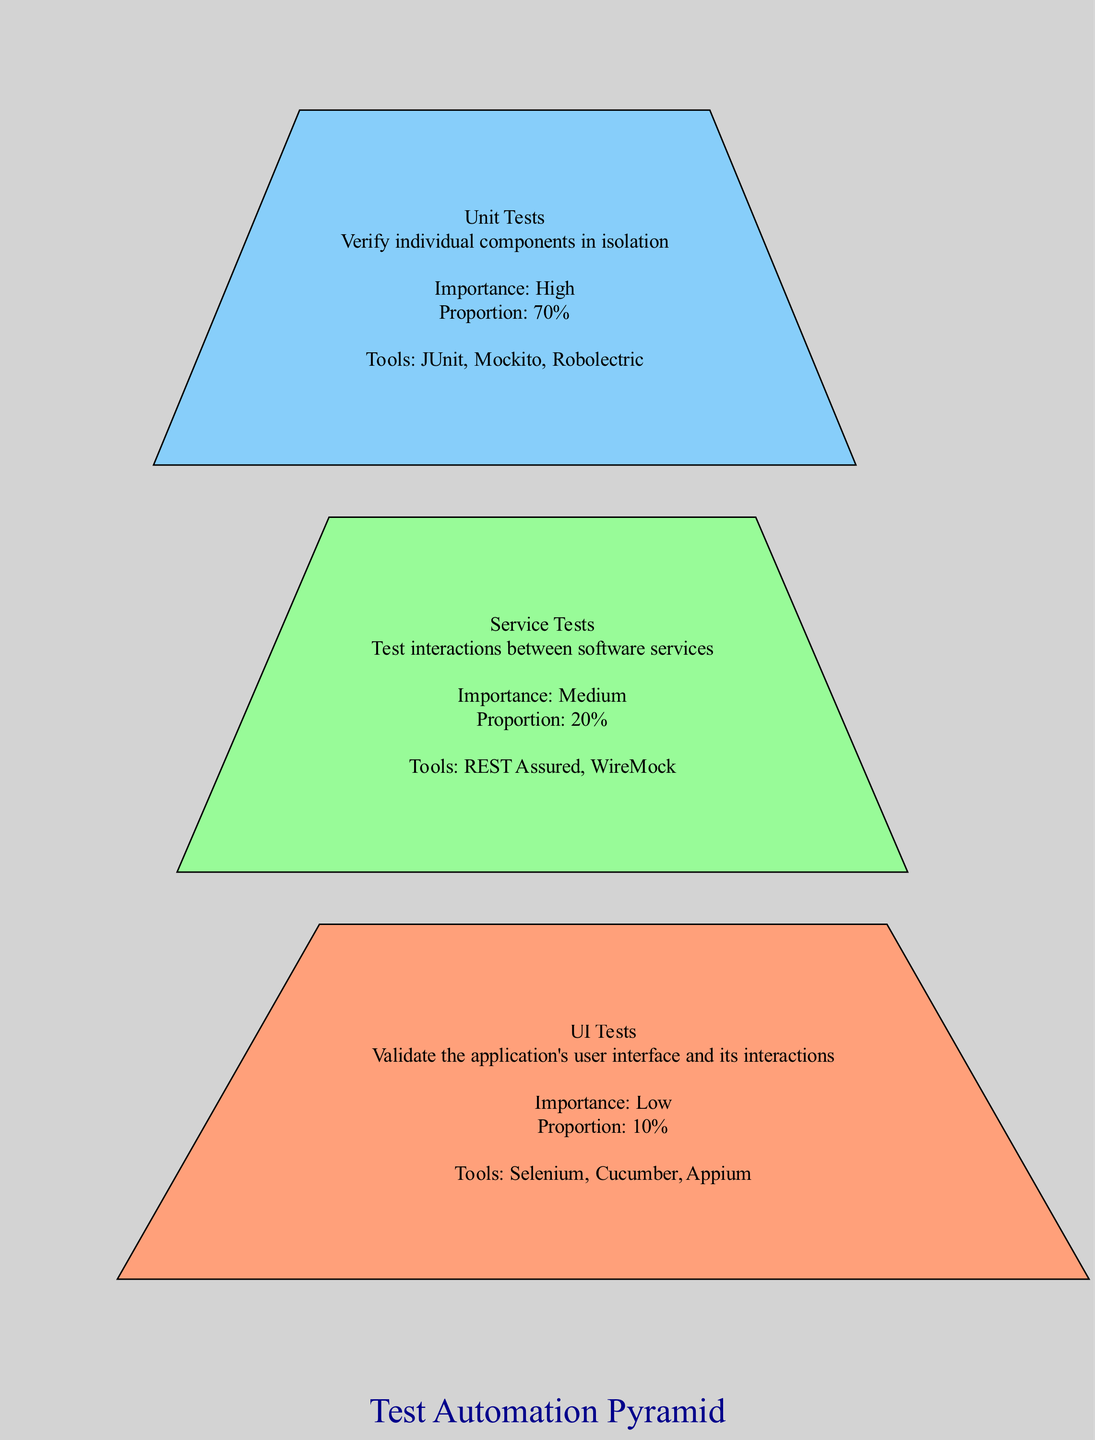What's the recommended proportion for Unit Tests? The proportion for Unit Tests is stated directly in the diagram under its description, which is 70%.
Answer: 70% What level has the highest importance? Reviewing the importance section for each level, Unit Tests are labeled with "High" importance, making it the highest.
Answer: High How many total levels are represented in the Test Automation Pyramid? The diagram presents three discrete levels: Unit Tests, Service Tests, and UI Tests. Thus, the total number of levels is three.
Answer: 3 What tools are recommended for UI Tests? The diagram lists the tools specifically associated with UI Tests, which includes Selenium, Cucumber, and Appium.
Answer: Selenium, Cucumber, Appium What is the importance level of Service Tests? Referring to the Service Tests section in the diagram, it explicitly states that the importance is "Medium."
Answer: Medium Which test level has the least recommended proportion? By examining the proportions stated for each level, UI Tests have the lowest recommended proportion at 10%.
Answer: 10% Why is the recommended proportion for Unit Tests so high? The diagram emphasizes that Unit Tests verify individual components in isolation, which is crucial for early bug detection and cost-effectiveness in the development process, justifying the high proportion.
Answer: High proportion due to effectiveness in early bug detection What tools are used for Service Tests? In the section dedicated to Service Tests, the diagram identifies the recommended tools as REST Assured and WireMock.
Answer: REST Assured, WireMock Which test level is at the top of the pyramid? The structure of the pyramid places Unit Tests at the top, indicated by its position and the decreasing order of proportions below it.
Answer: Unit Tests 